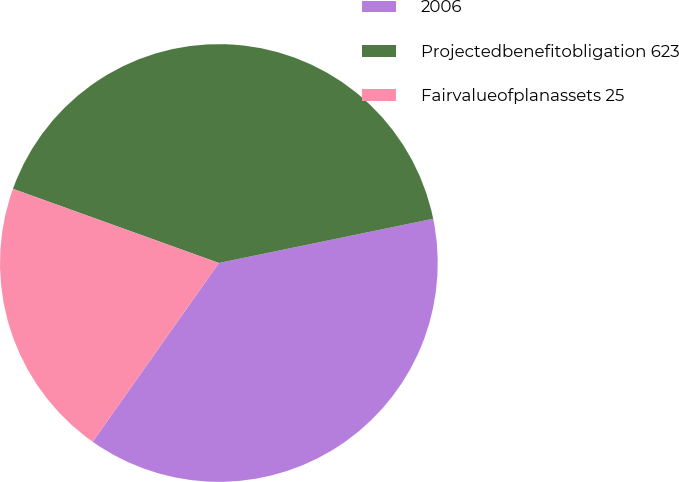Convert chart to OTSL. <chart><loc_0><loc_0><loc_500><loc_500><pie_chart><fcel>2006<fcel>Projectedbenefitobligation 623<fcel>Fairvalueofplanassets 25<nl><fcel>38.02%<fcel>41.26%<fcel>20.72%<nl></chart> 